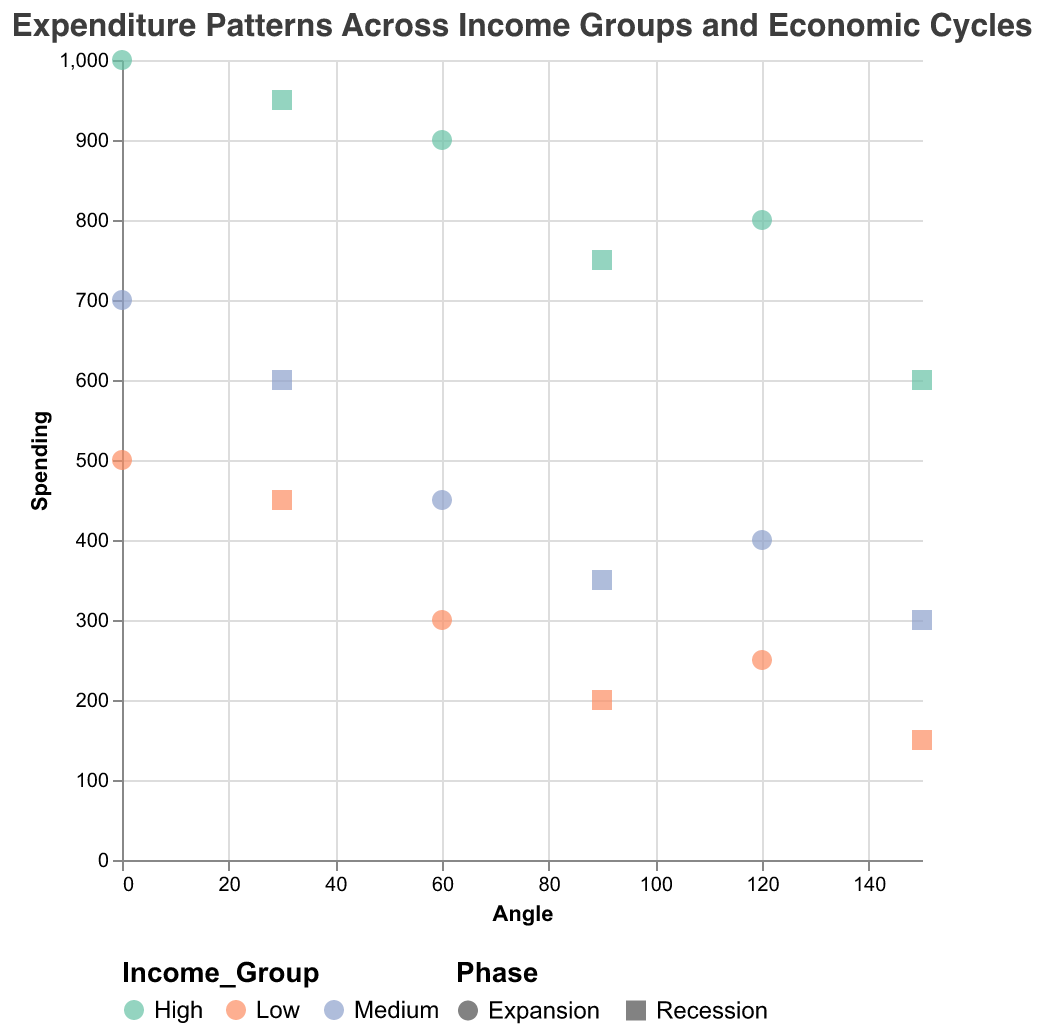What is the title of the chart? The title is at the top of the chart. It reads: "Expenditure Patterns Across Income Groups and Economic Cycles"
Answer: Expenditure Patterns Across Income Groups and Economic Cycles How many phases of the economic cycle are shown in the chart? The chart highlights the phases "Expansion" and "Recession" indicated by different shapes in the legend. There are two phases overall.
Answer: 2 Which income group spends the most on essential goods during the expansion phase? Examine the points labeled "Essential Goods" with the "Expansion" phase. The High-income group spends the most with a spending of 1000.
Answer: High What is the angle for non-essential goods during the recession phase? Locate points under "Non-Essential Goods" during "Recession". The angle for these data points is 90 degrees for all income groups.
Answer: 90 How does spending on services change from expansion to recession for the low-income group? For "Low" income group, find points labeled "Services" and compare "Expansion" (250) to "Recession" (150). The spending decreases by 100.
Answer: Decreases by 100 Which income group shows the smallest change in spending on essential goods between expansion and recession? Review "Essential Goods" for each income group in "Expansion" and "Recession". Calculate the differences: Low (50), Medium (100), High (50). Both Low and High have the smallest change (50).
Answer: Low, High What is the average spending for the medium-income group on non-essential goods across both economic phases? For "Medium" income group and "Non-Essential Goods," sum spending in "Expansion" (450) and "Recession" (350), divide by 2. (450 + 350) / 2 = 400
Answer: 400 Compare spending on services during the recession phase across all income groups. Which group spends the most? Isolate "Recession" phase and "Services" category for all groups: Low (150), Medium (300), High (600). High-income group spends the most.
Answer: High What trend can be observed in spending on essential goods across different income groups during the recession phase? Compare spending on "Essential Goods" during "Recession": Low (450), Medium (600), High (950). Spending increases with income level.
Answer: Increases with income level 